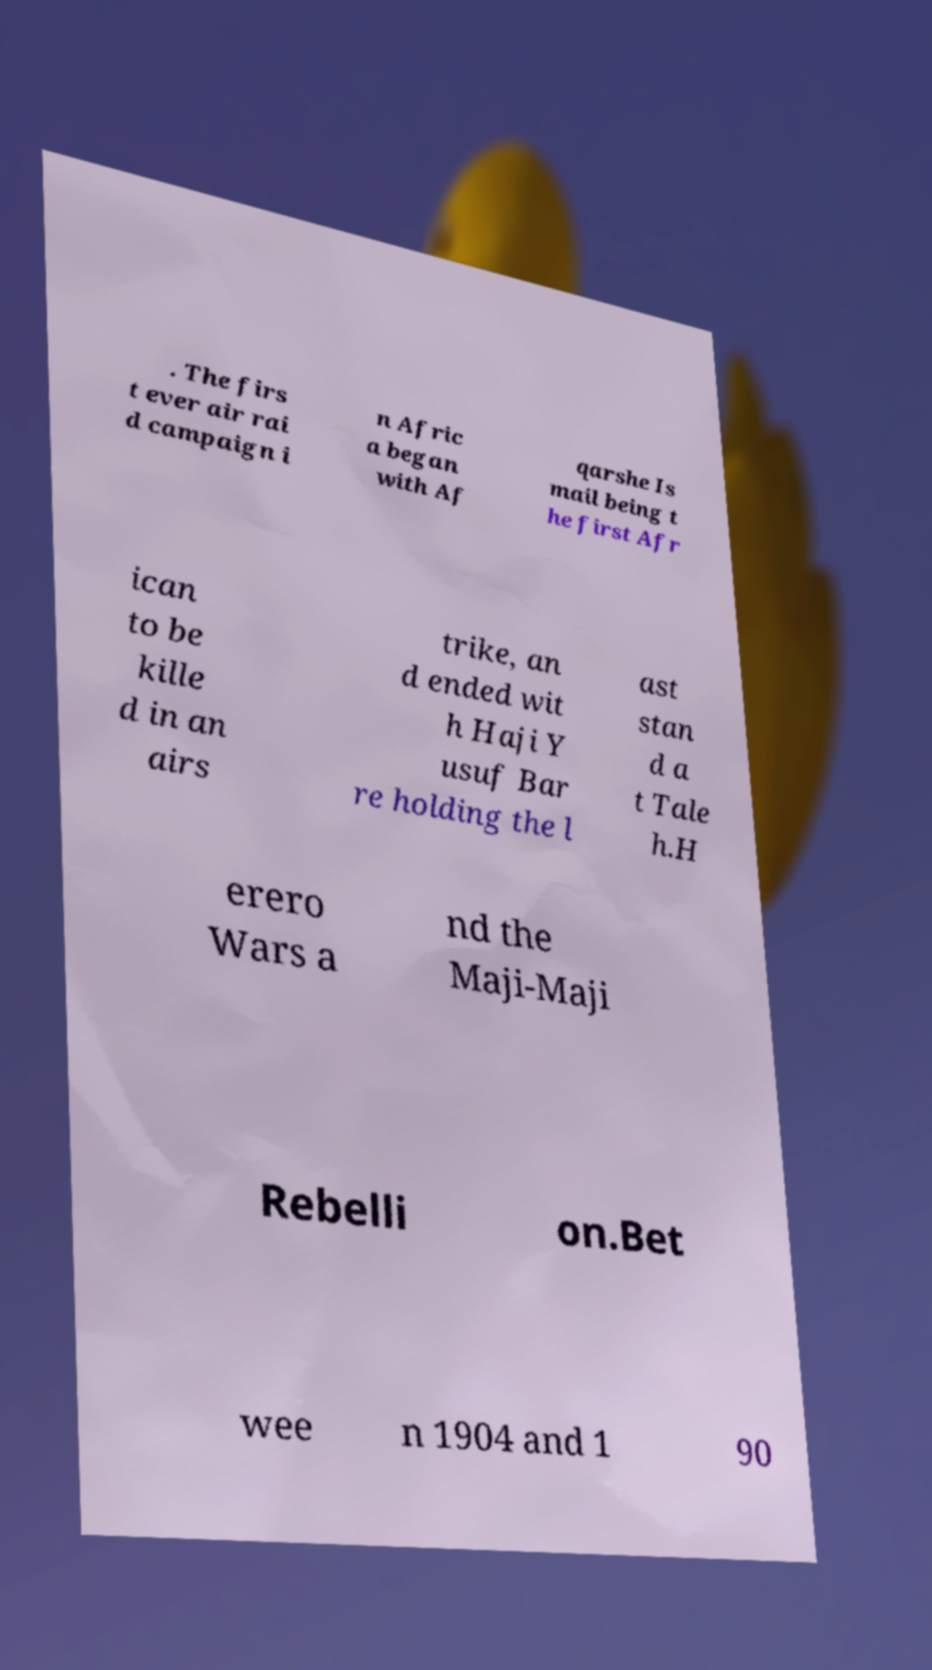Could you extract and type out the text from this image? . The firs t ever air rai d campaign i n Afric a began with Af qarshe Is mail being t he first Afr ican to be kille d in an airs trike, an d ended wit h Haji Y usuf Bar re holding the l ast stan d a t Tale h.H erero Wars a nd the Maji-Maji Rebelli on.Bet wee n 1904 and 1 90 